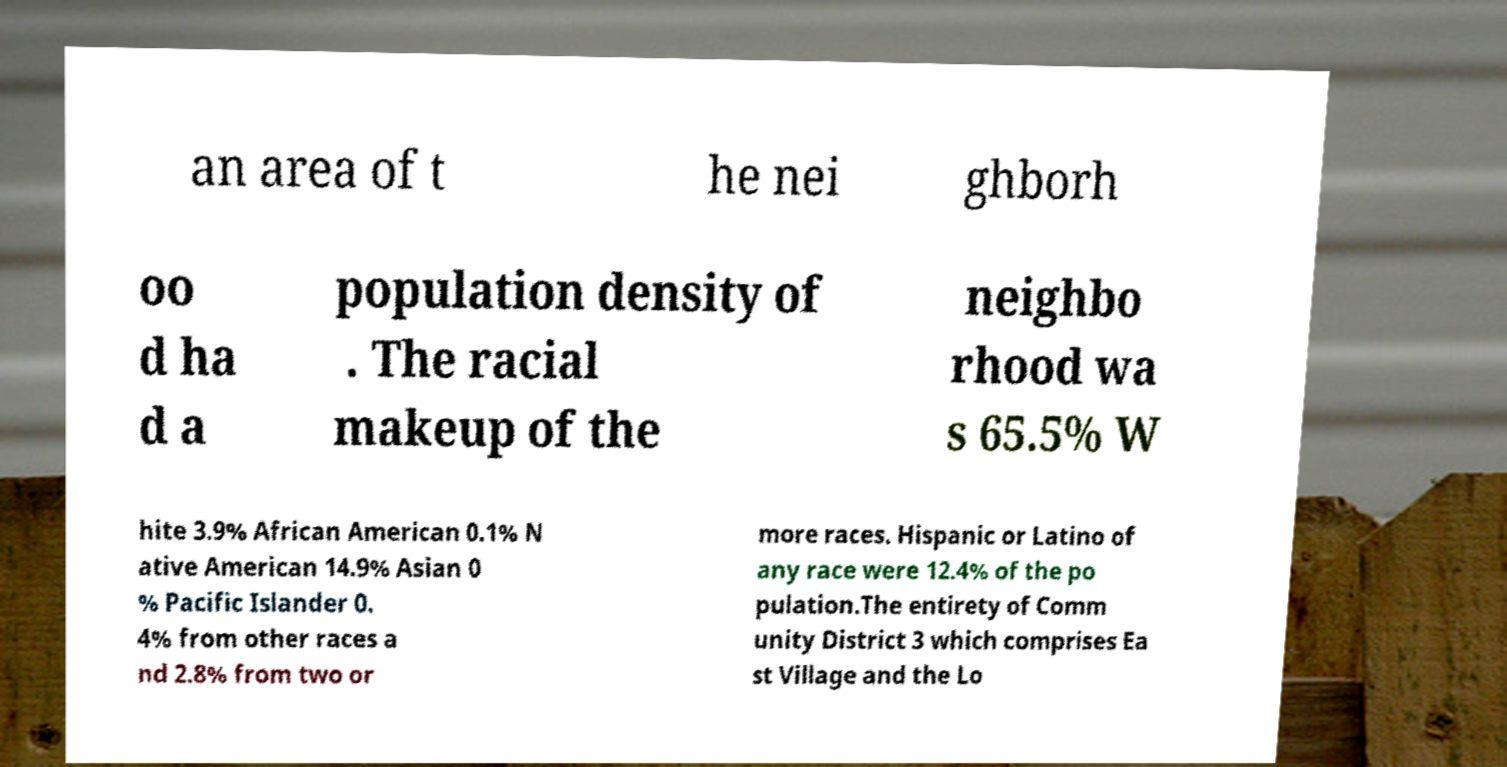There's text embedded in this image that I need extracted. Can you transcribe it verbatim? an area of t he nei ghborh oo d ha d a population density of . The racial makeup of the neighbo rhood wa s 65.5% W hite 3.9% African American 0.1% N ative American 14.9% Asian 0 % Pacific Islander 0. 4% from other races a nd 2.8% from two or more races. Hispanic or Latino of any race were 12.4% of the po pulation.The entirety of Comm unity District 3 which comprises Ea st Village and the Lo 